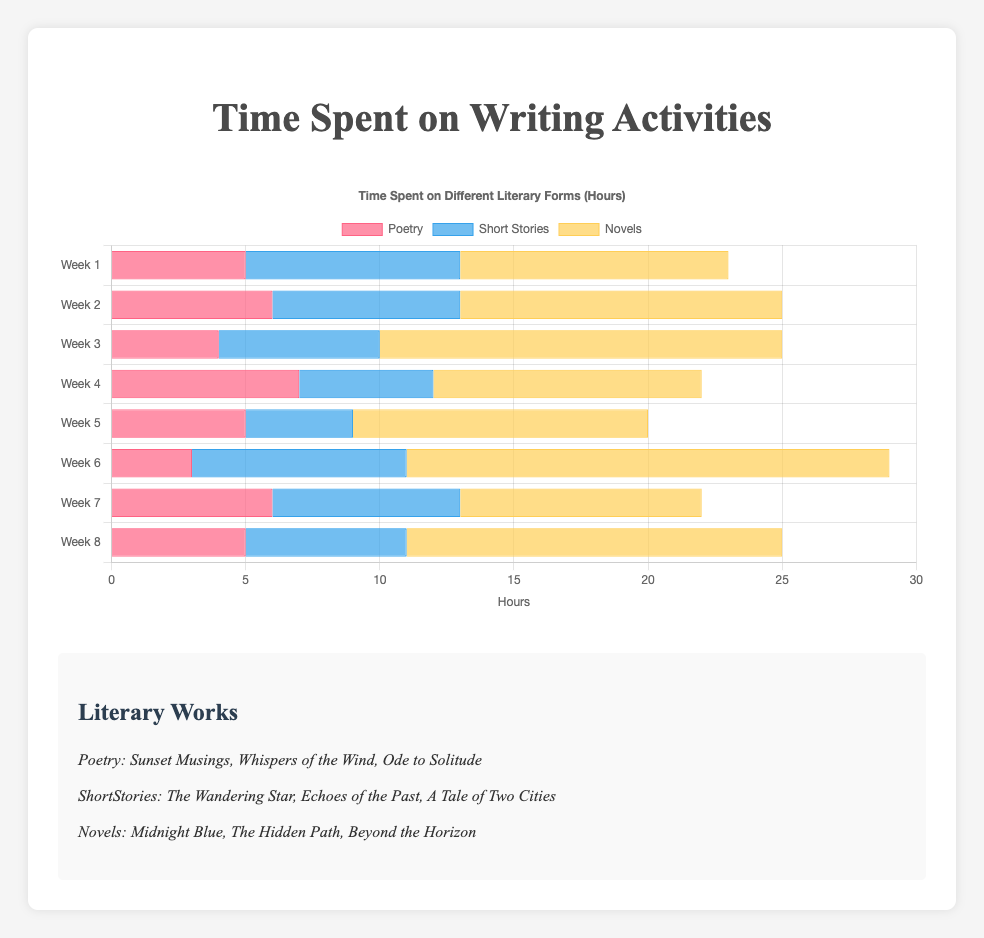Which week had the highest time spent on Novels? To find the week with the highest time spent on Novels, look for the bar with the greatest length in the 'Novels' category. Weeks 6, 3, and 8 have notable tall bars, but Week 6 has the tallest at 18 hours.
Answer: Week 6 What is the total time spent on Poetry over all weeks? Sum the heights of all Poetry bars across each week: 5 + 6 + 4 + 7 + 5 + 3 + 6 + 5 = 41 hours
Answer: 41 hours Which literary form had the least amount of time spent in Week 4? Compare the bar lengths for Week 4. Poetry (7), Short Stories (5), and Novels (10). Short Stories have the shortest bar.
Answer: Short Stories What is the average time spent on Short Stories per week? Sum all weekly times for Short Stories and divide by the number of weeks: (8 + 7 + 6 + 5 + 4 + 8 + 7 + 6) / 8 = 51 / 8 = 6.375 hours
Answer: 6.375 hours Compare the time spent on Novels and Short Stories in Week 2. Which had more and by how much? In Week 2, the bar for Novels is at 12 hours, and for Short Stories, it is at 7 hours. Subtract the smaller value from the larger: 12 - 7 = 5 hours. Novels had more.
Answer: Novels, 5 hours more How much more time was spent on Poetry in Week 4 compared to Week 6? Look at both weeks' Poetry bars. Week 4 has 7 hours, Week 6 has 3 hours. Subtract Week 6 from Week 4: 7 - 3 = 4 hours.
Answer: 4 hours What is the highest weekly time spent on Short Stories? From all the Short Stories bars, identify the highest. Weeks 1 and 6 both have the highest bar at 8 hours.
Answer: 8 hours Compare the total time spent on all activities (Poetry, Short Stories, and Novels) in Week 5. What is the combined time? Add the lengths of all bars for Week 5. Poetry (5), Short Stories (4), Novels (11): 5 + 4 + 11 = 20 hours.
Answer: 20 hours During which week did the time spent on Poetry equal the time spent on Short Stories? Look for weeks where the Poetry and Short Stories bars are equal in length. Week 7 and Week 8 both show coinciding heights of 6 hours.
Answer: Week 7, Week 8 